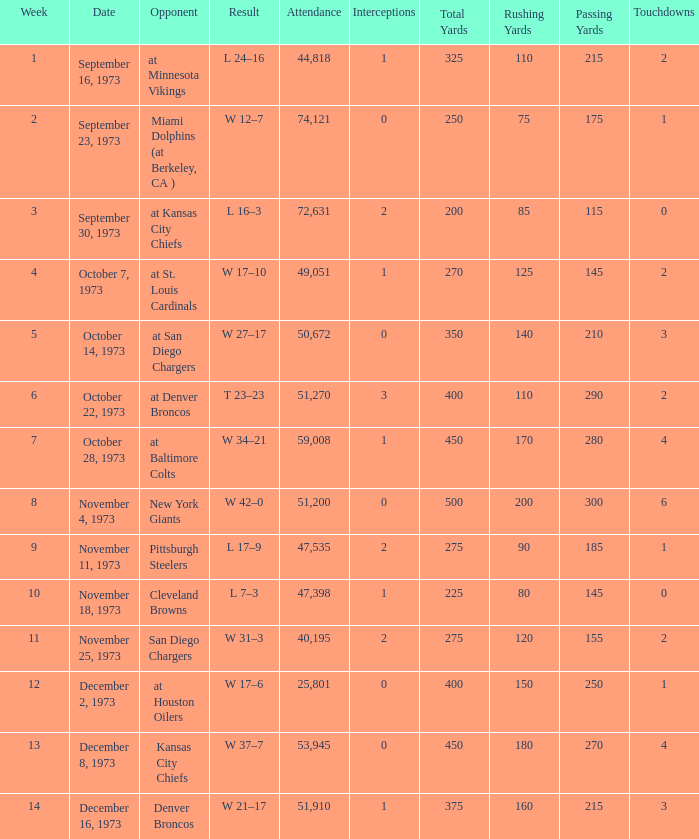What is the result later than week 13? W 21–17. 